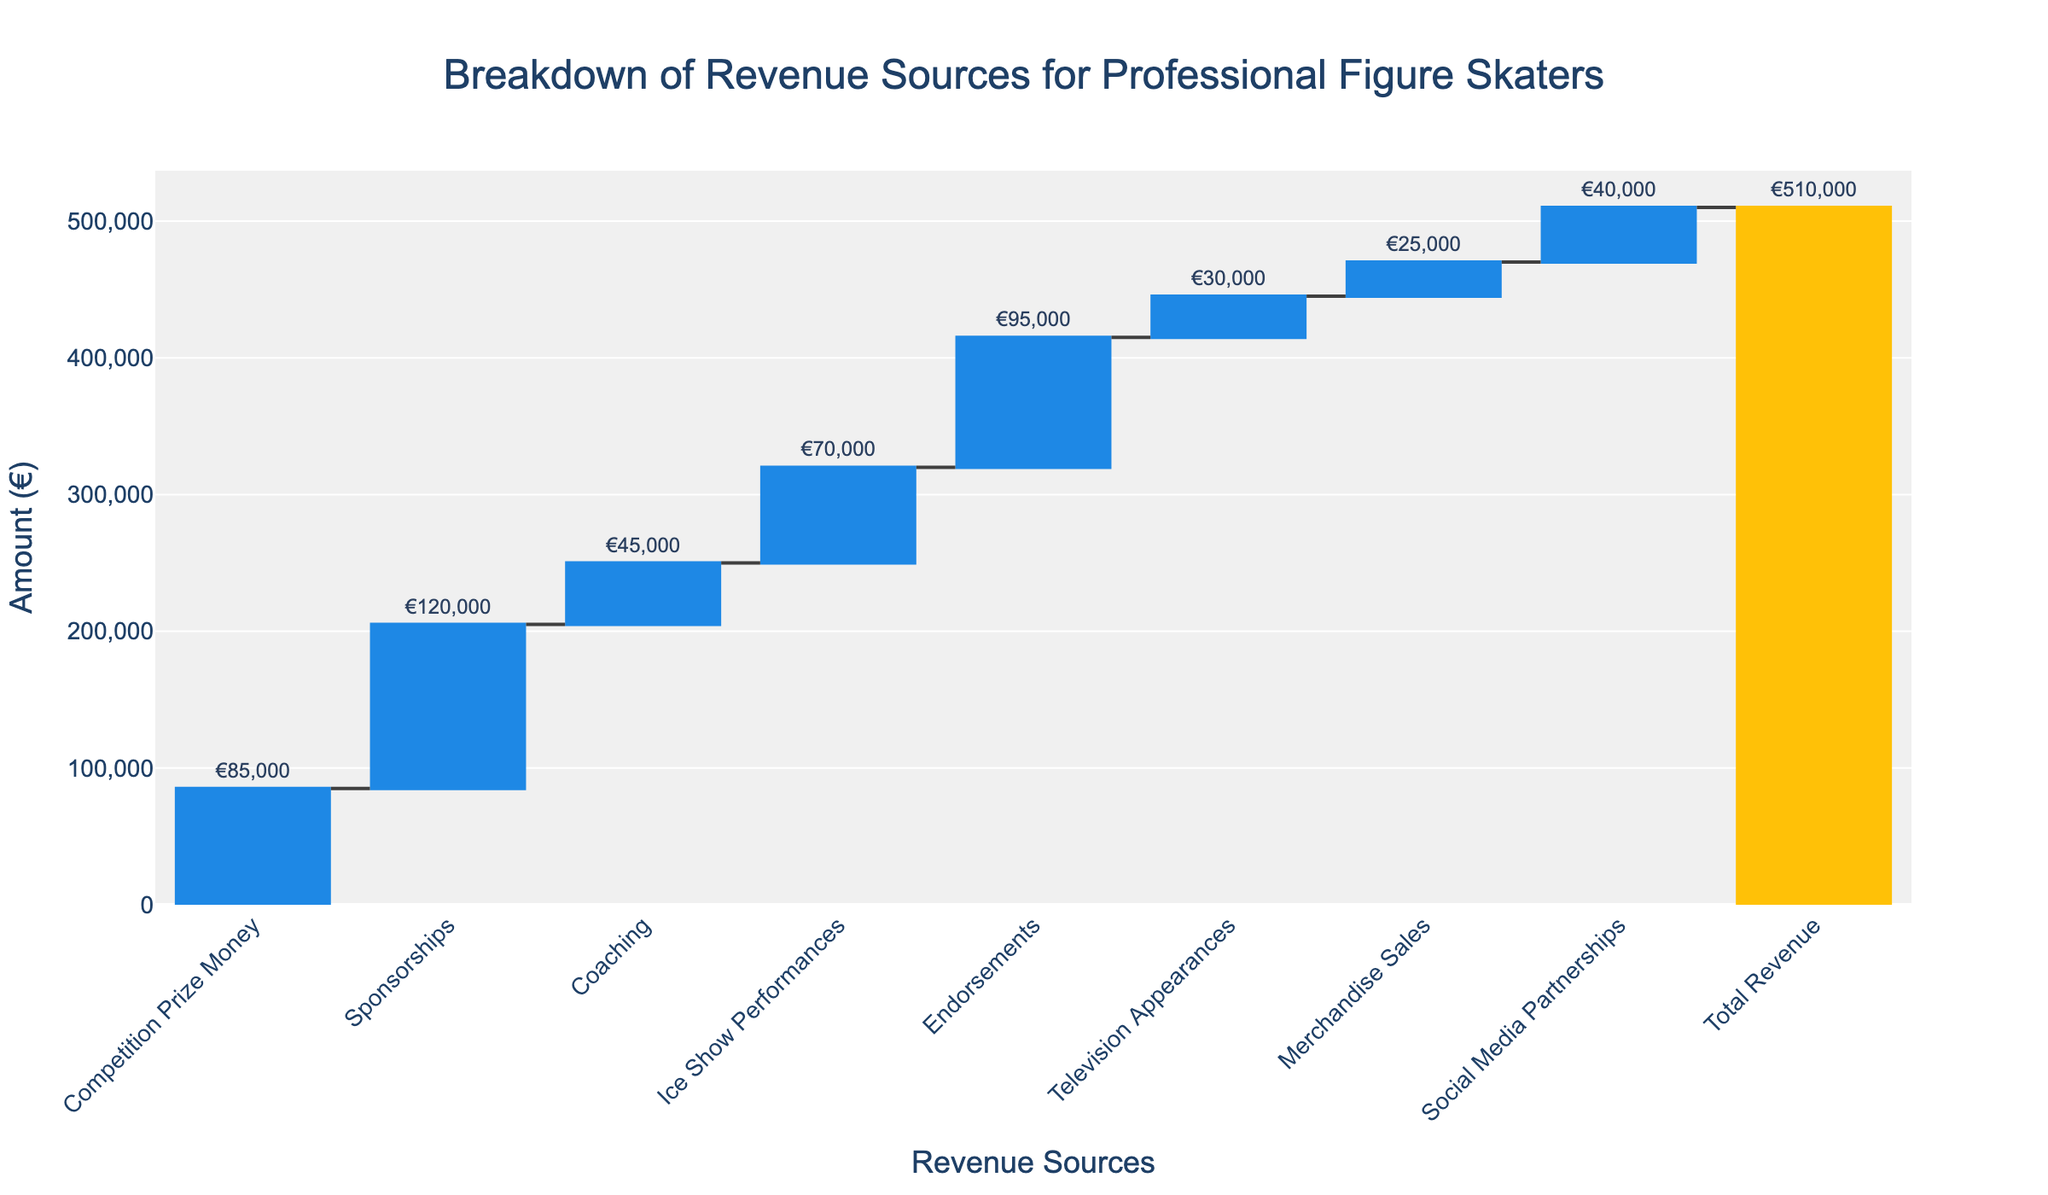What is the title of the chart? The title is situated at the top of the chart and generally describes the content of the figure.
Answer: Breakdown of Revenue Sources for Professional Figure Skaters What is the total revenue for professional figure skaters? The total revenue is explicitly stated at the end of the waterfall chart, generally highlighted in a unique color to stand out.
Answer: €510,000 What revenue source contributes the most to the total revenue? By examining the height of the bars, the sponsorships category is the tallest, indicating it has the highest value.
Answer: Sponsorships How much revenue comes from television appearances and merchandise sales combined? Adding the values from television appearances (€30,000) and merchandise sales (€25,000) gives the total for these two categories. (€30,000 + €25,000)
Answer: €55,000 Which revenue source contributes the least to the total revenue? The shortest bar in the waterfall chart represents the income source with the smallest value, which is merchandise sales.
Answer: Merchandise Sales What is the difference in revenue between ice show performances and coaching? Subtract the value of coaching (€45,000) from the value of ice show performances (€70,000). (€70,000 - €45,000)
Answer: €25,000 Between endorsements and competition prize money, which contributes more revenue and by how much? Compare the heights of the bars representing endorsements (€95,000) and competition prize money (€85,000) and find the difference. (€95,000 - €85,000)
Answer: Endorsements by €10,000 How many categories contribute to the total revenue before the final aggregation to Total Revenue? Count the number of individual bars before the final Total Revenue bar.
Answer: 8 If coaching and social media partnerships were combined into a single category, what would their total revenue be? Add the values from coaching (€45,000) and social media partnerships (€40,000) to get the combined total. (€45,000 + €40,000)
Answer: €85,000 